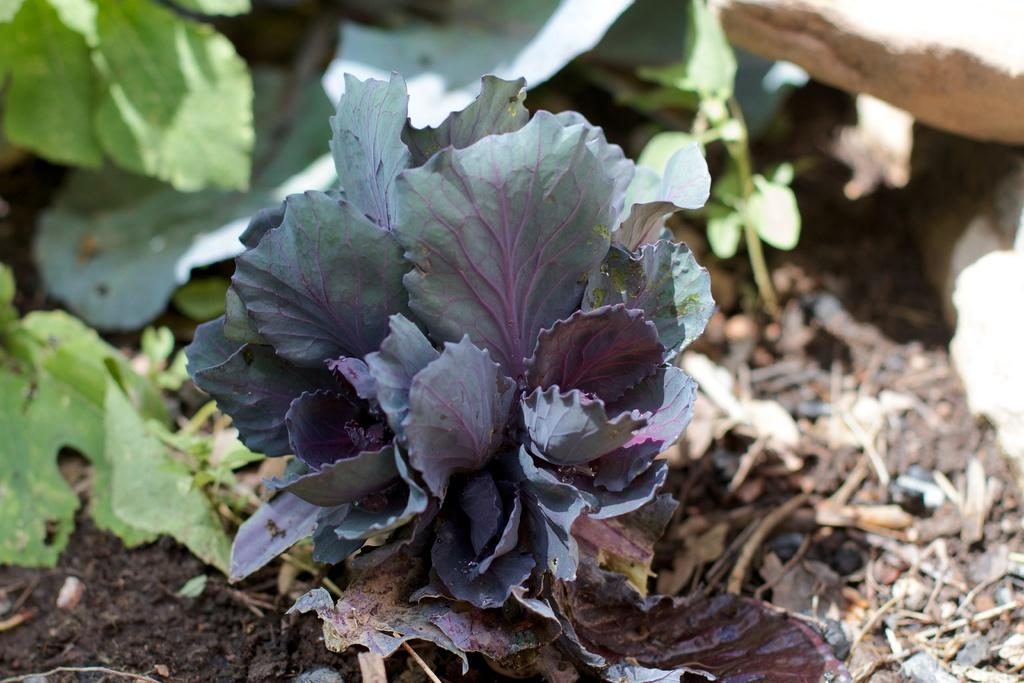What type of living organisms can be seen in the image? Plants can be seen in the image. What can be found on the ground in the image? There are stones and leaves on the ground in the image. What type of drum can be seen in the image? There is no drum present in the image. Can you describe the stranger in the image? There is no stranger present in the image. 